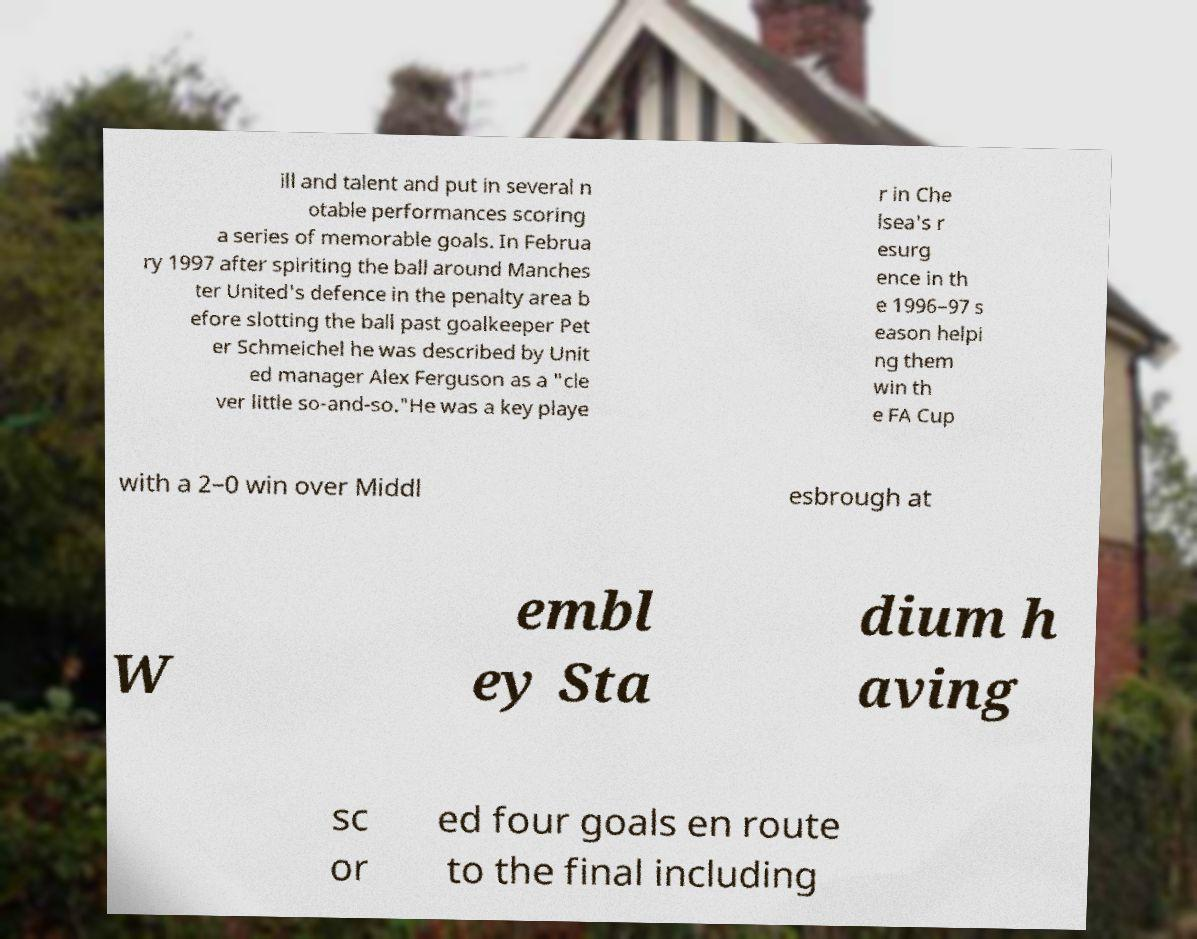Can you read and provide the text displayed in the image?This photo seems to have some interesting text. Can you extract and type it out for me? ill and talent and put in several n otable performances scoring a series of memorable goals. In Februa ry 1997 after spiriting the ball around Manches ter United's defence in the penalty area b efore slotting the ball past goalkeeper Pet er Schmeichel he was described by Unit ed manager Alex Ferguson as a "cle ver little so-and-so."He was a key playe r in Che lsea's r esurg ence in th e 1996–97 s eason helpi ng them win th e FA Cup with a 2–0 win over Middl esbrough at W embl ey Sta dium h aving sc or ed four goals en route to the final including 